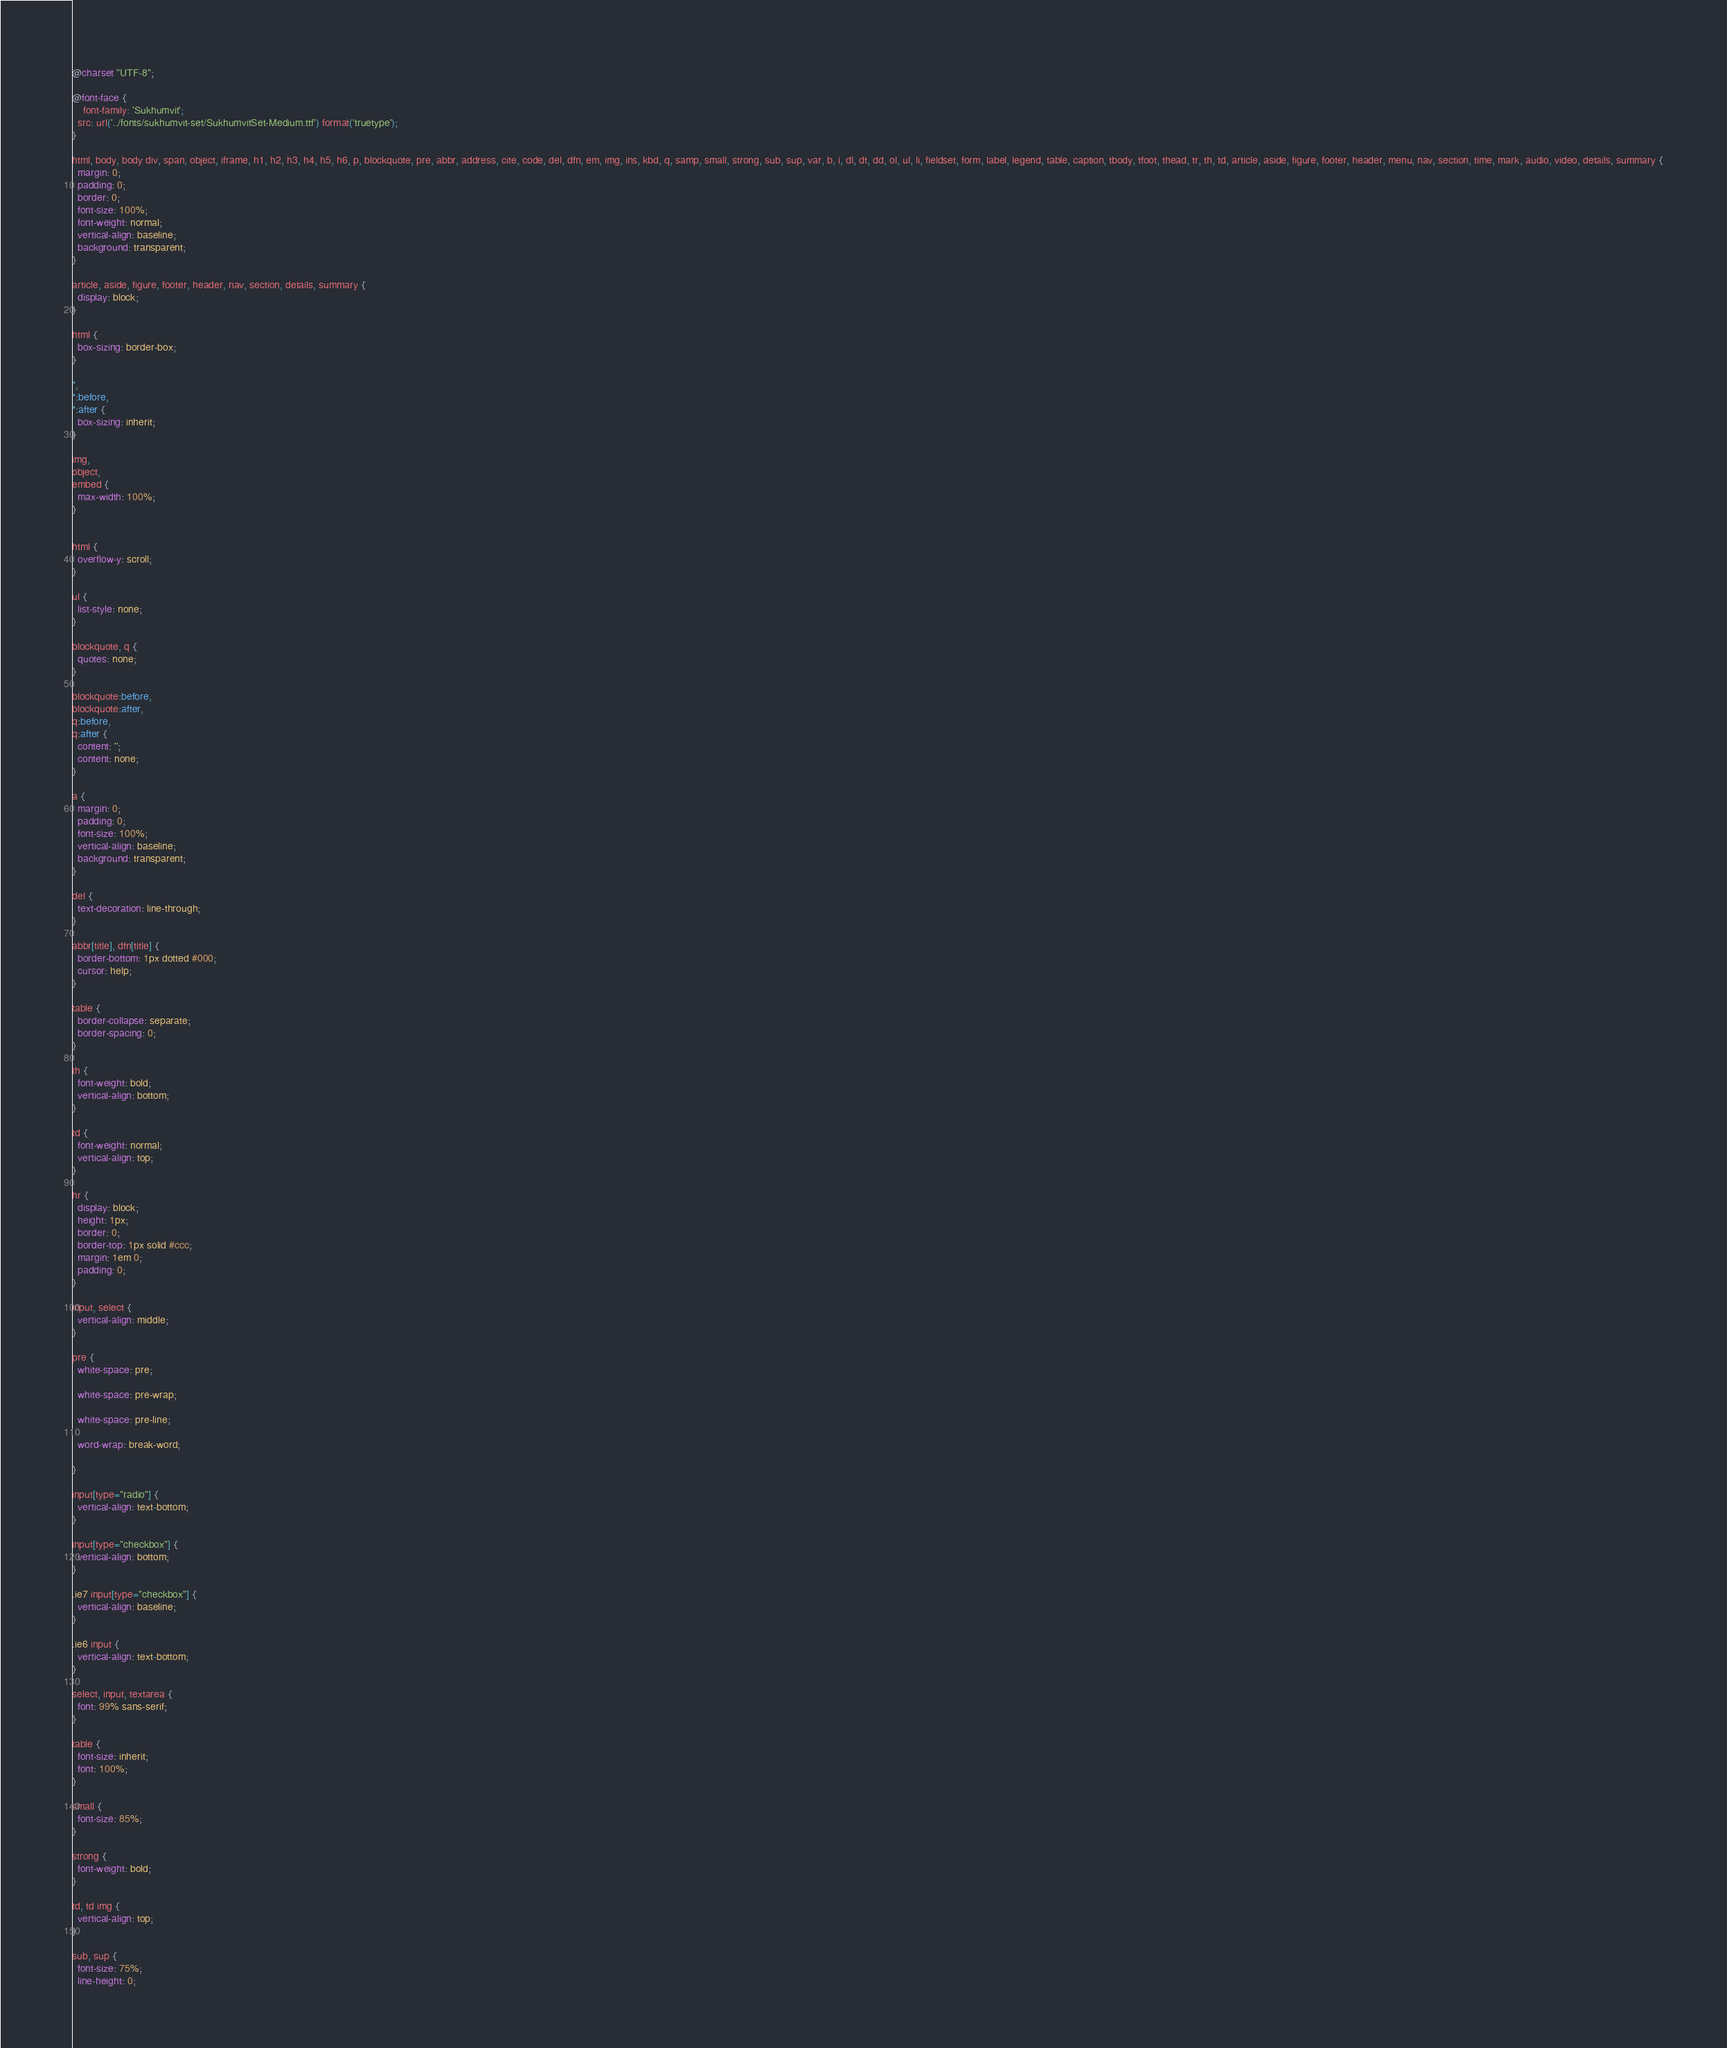Convert code to text. <code><loc_0><loc_0><loc_500><loc_500><_CSS_>@charset "UTF-8";

@font-face {
	font-family: 'Sukhumvit';
  src: url('../fonts/sukhumvit-set/SukhumvitSet-Medium.ttf') format('truetype');
}

html, body, body div, span, object, iframe, h1, h2, h3, h4, h5, h6, p, blockquote, pre, abbr, address, cite, code, del, dfn, em, img, ins, kbd, q, samp, small, strong, sub, sup, var, b, i, dl, dt, dd, ol, ul, li, fieldset, form, label, legend, table, caption, tbody, tfoot, thead, tr, th, td, article, aside, figure, footer, header, menu, nav, section, time, mark, audio, video, details, summary {
  margin: 0;
  padding: 0;
  border: 0;
  font-size: 100%;
  font-weight: normal;
  vertical-align: baseline;
  background: transparent;
}

article, aside, figure, footer, header, nav, section, details, summary {
  display: block;
}

html {
  box-sizing: border-box;
}

*,
*:before,
*:after {
  box-sizing: inherit;
}

img,
object,
embed {
  max-width: 100%;
}


html {
  overflow-y: scroll;
}

ul {
  list-style: none;
}

blockquote, q {
  quotes: none;
}

blockquote:before,
blockquote:after,
q:before,
q:after {
  content: '';
  content: none;
}

a {
  margin: 0;
  padding: 0;
  font-size: 100%;
  vertical-align: baseline;
  background: transparent;
}

del {
  text-decoration: line-through;
}

abbr[title], dfn[title] {
  border-bottom: 1px dotted #000;
  cursor: help;
}

table {
  border-collapse: separate;
  border-spacing: 0;
}

th {
  font-weight: bold;
  vertical-align: bottom;
}

td {
  font-weight: normal;
  vertical-align: top;
}

hr {
  display: block;
  height: 1px;
  border: 0;
  border-top: 1px solid #ccc;
  margin: 1em 0;
  padding: 0;
}

input, select {
  vertical-align: middle;
}

pre {
  white-space: pre;

  white-space: pre-wrap;

  white-space: pre-line;

  word-wrap: break-word;

}

input[type="radio"] {
  vertical-align: text-bottom;
}

input[type="checkbox"] {
  vertical-align: bottom;
}

.ie7 input[type="checkbox"] {
  vertical-align: baseline;
}

.ie6 input {
  vertical-align: text-bottom;
}

select, input, textarea {
  font: 99% sans-serif;
}

table {
  font-size: inherit;
  font: 100%;
}

small {
  font-size: 85%;
}

strong {
  font-weight: bold;
}

td, td img {
  vertical-align: top;
}

sub, sup {
  font-size: 75%;
  line-height: 0;</code> 